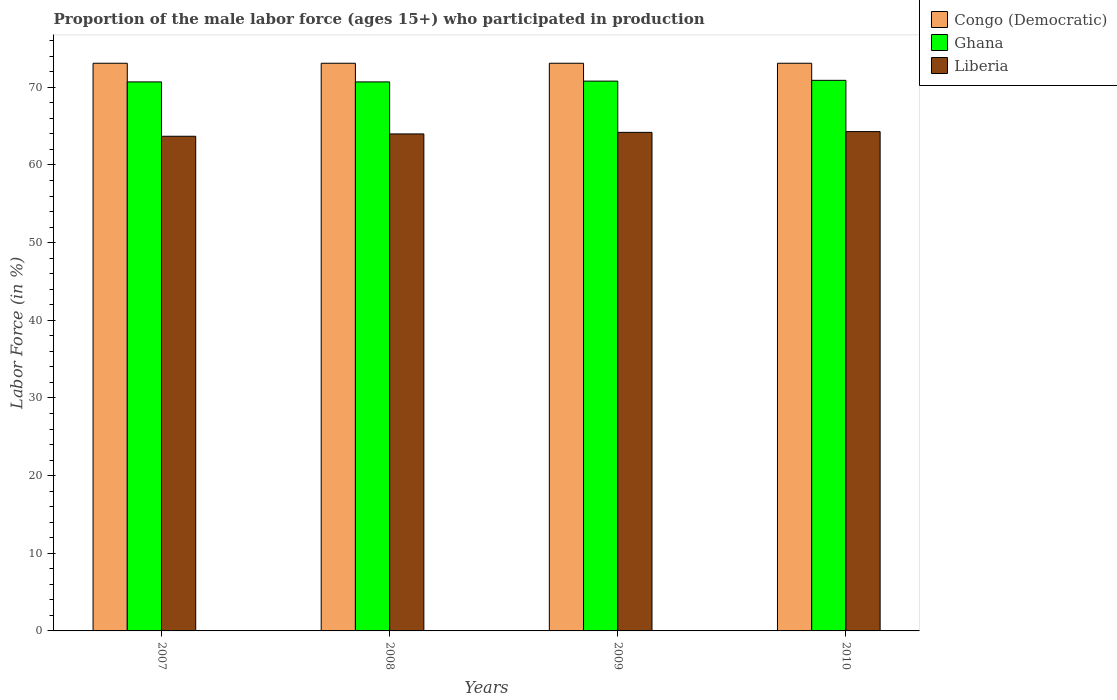How many different coloured bars are there?
Give a very brief answer. 3. Are the number of bars per tick equal to the number of legend labels?
Give a very brief answer. Yes. How many bars are there on the 3rd tick from the left?
Keep it short and to the point. 3. What is the label of the 4th group of bars from the left?
Make the answer very short. 2010. In how many cases, is the number of bars for a given year not equal to the number of legend labels?
Your answer should be very brief. 0. What is the proportion of the male labor force who participated in production in Ghana in 2007?
Provide a short and direct response. 70.7. Across all years, what is the maximum proportion of the male labor force who participated in production in Congo (Democratic)?
Offer a terse response. 73.1. Across all years, what is the minimum proportion of the male labor force who participated in production in Congo (Democratic)?
Make the answer very short. 73.1. What is the total proportion of the male labor force who participated in production in Congo (Democratic) in the graph?
Your response must be concise. 292.4. What is the difference between the proportion of the male labor force who participated in production in Congo (Democratic) in 2007 and that in 2010?
Provide a succinct answer. 0. What is the difference between the proportion of the male labor force who participated in production in Liberia in 2007 and the proportion of the male labor force who participated in production in Ghana in 2009?
Offer a terse response. -7.1. What is the average proportion of the male labor force who participated in production in Liberia per year?
Offer a very short reply. 64.05. In the year 2008, what is the difference between the proportion of the male labor force who participated in production in Congo (Democratic) and proportion of the male labor force who participated in production in Liberia?
Make the answer very short. 9.1. What is the ratio of the proportion of the male labor force who participated in production in Liberia in 2007 to that in 2009?
Ensure brevity in your answer.  0.99. Is the difference between the proportion of the male labor force who participated in production in Congo (Democratic) in 2007 and 2009 greater than the difference between the proportion of the male labor force who participated in production in Liberia in 2007 and 2009?
Your response must be concise. Yes. What is the difference between the highest and the second highest proportion of the male labor force who participated in production in Liberia?
Offer a terse response. 0.1. In how many years, is the proportion of the male labor force who participated in production in Ghana greater than the average proportion of the male labor force who participated in production in Ghana taken over all years?
Your answer should be compact. 2. What does the 1st bar from the left in 2009 represents?
Your answer should be very brief. Congo (Democratic). What does the 1st bar from the right in 2009 represents?
Keep it short and to the point. Liberia. How many bars are there?
Keep it short and to the point. 12. Are all the bars in the graph horizontal?
Your answer should be compact. No. What is the difference between two consecutive major ticks on the Y-axis?
Ensure brevity in your answer.  10. Where does the legend appear in the graph?
Provide a succinct answer. Top right. How are the legend labels stacked?
Make the answer very short. Vertical. What is the title of the graph?
Give a very brief answer. Proportion of the male labor force (ages 15+) who participated in production. Does "Curacao" appear as one of the legend labels in the graph?
Offer a terse response. No. What is the label or title of the Y-axis?
Offer a terse response. Labor Force (in %). What is the Labor Force (in %) of Congo (Democratic) in 2007?
Your answer should be compact. 73.1. What is the Labor Force (in %) of Ghana in 2007?
Make the answer very short. 70.7. What is the Labor Force (in %) in Liberia in 2007?
Give a very brief answer. 63.7. What is the Labor Force (in %) in Congo (Democratic) in 2008?
Ensure brevity in your answer.  73.1. What is the Labor Force (in %) in Ghana in 2008?
Keep it short and to the point. 70.7. What is the Labor Force (in %) in Congo (Democratic) in 2009?
Offer a very short reply. 73.1. What is the Labor Force (in %) of Ghana in 2009?
Offer a very short reply. 70.8. What is the Labor Force (in %) in Liberia in 2009?
Give a very brief answer. 64.2. What is the Labor Force (in %) in Congo (Democratic) in 2010?
Your answer should be compact. 73.1. What is the Labor Force (in %) of Ghana in 2010?
Provide a short and direct response. 70.9. What is the Labor Force (in %) in Liberia in 2010?
Your answer should be compact. 64.3. Across all years, what is the maximum Labor Force (in %) in Congo (Democratic)?
Provide a short and direct response. 73.1. Across all years, what is the maximum Labor Force (in %) of Ghana?
Your answer should be very brief. 70.9. Across all years, what is the maximum Labor Force (in %) in Liberia?
Give a very brief answer. 64.3. Across all years, what is the minimum Labor Force (in %) in Congo (Democratic)?
Your answer should be very brief. 73.1. Across all years, what is the minimum Labor Force (in %) in Ghana?
Provide a short and direct response. 70.7. Across all years, what is the minimum Labor Force (in %) of Liberia?
Your answer should be very brief. 63.7. What is the total Labor Force (in %) of Congo (Democratic) in the graph?
Your answer should be very brief. 292.4. What is the total Labor Force (in %) in Ghana in the graph?
Ensure brevity in your answer.  283.1. What is the total Labor Force (in %) of Liberia in the graph?
Your response must be concise. 256.2. What is the difference between the Labor Force (in %) of Liberia in 2007 and that in 2008?
Your response must be concise. -0.3. What is the difference between the Labor Force (in %) in Congo (Democratic) in 2007 and that in 2009?
Provide a succinct answer. 0. What is the difference between the Labor Force (in %) in Liberia in 2007 and that in 2009?
Your answer should be compact. -0.5. What is the difference between the Labor Force (in %) of Congo (Democratic) in 2007 and that in 2010?
Provide a short and direct response. 0. What is the difference between the Labor Force (in %) in Ghana in 2007 and that in 2010?
Make the answer very short. -0.2. What is the difference between the Labor Force (in %) in Congo (Democratic) in 2008 and that in 2009?
Keep it short and to the point. 0. What is the difference between the Labor Force (in %) of Ghana in 2008 and that in 2009?
Ensure brevity in your answer.  -0.1. What is the difference between the Labor Force (in %) of Liberia in 2008 and that in 2009?
Offer a very short reply. -0.2. What is the difference between the Labor Force (in %) of Liberia in 2008 and that in 2010?
Provide a succinct answer. -0.3. What is the difference between the Labor Force (in %) of Congo (Democratic) in 2009 and that in 2010?
Ensure brevity in your answer.  0. What is the difference between the Labor Force (in %) in Ghana in 2007 and the Labor Force (in %) in Liberia in 2009?
Make the answer very short. 6.5. What is the difference between the Labor Force (in %) of Congo (Democratic) in 2007 and the Labor Force (in %) of Liberia in 2010?
Give a very brief answer. 8.8. What is the difference between the Labor Force (in %) of Congo (Democratic) in 2008 and the Labor Force (in %) of Ghana in 2009?
Offer a terse response. 2.3. What is the difference between the Labor Force (in %) of Congo (Democratic) in 2008 and the Labor Force (in %) of Liberia in 2009?
Offer a terse response. 8.9. What is the difference between the Labor Force (in %) of Congo (Democratic) in 2008 and the Labor Force (in %) of Liberia in 2010?
Provide a succinct answer. 8.8. What is the difference between the Labor Force (in %) in Ghana in 2008 and the Labor Force (in %) in Liberia in 2010?
Your response must be concise. 6.4. What is the difference between the Labor Force (in %) of Congo (Democratic) in 2009 and the Labor Force (in %) of Ghana in 2010?
Your answer should be compact. 2.2. What is the difference between the Labor Force (in %) in Congo (Democratic) in 2009 and the Labor Force (in %) in Liberia in 2010?
Your response must be concise. 8.8. What is the difference between the Labor Force (in %) in Ghana in 2009 and the Labor Force (in %) in Liberia in 2010?
Provide a succinct answer. 6.5. What is the average Labor Force (in %) of Congo (Democratic) per year?
Keep it short and to the point. 73.1. What is the average Labor Force (in %) of Ghana per year?
Keep it short and to the point. 70.78. What is the average Labor Force (in %) in Liberia per year?
Ensure brevity in your answer.  64.05. In the year 2007, what is the difference between the Labor Force (in %) in Congo (Democratic) and Labor Force (in %) in Ghana?
Keep it short and to the point. 2.4. In the year 2007, what is the difference between the Labor Force (in %) in Congo (Democratic) and Labor Force (in %) in Liberia?
Keep it short and to the point. 9.4. In the year 2007, what is the difference between the Labor Force (in %) of Ghana and Labor Force (in %) of Liberia?
Keep it short and to the point. 7. In the year 2008, what is the difference between the Labor Force (in %) of Congo (Democratic) and Labor Force (in %) of Liberia?
Offer a terse response. 9.1. In the year 2008, what is the difference between the Labor Force (in %) of Ghana and Labor Force (in %) of Liberia?
Your answer should be very brief. 6.7. In the year 2009, what is the difference between the Labor Force (in %) in Congo (Democratic) and Labor Force (in %) in Liberia?
Offer a very short reply. 8.9. In the year 2010, what is the difference between the Labor Force (in %) in Congo (Democratic) and Labor Force (in %) in Liberia?
Ensure brevity in your answer.  8.8. What is the ratio of the Labor Force (in %) in Congo (Democratic) in 2007 to that in 2008?
Offer a terse response. 1. What is the ratio of the Labor Force (in %) of Ghana in 2007 to that in 2008?
Your answer should be compact. 1. What is the ratio of the Labor Force (in %) of Liberia in 2007 to that in 2008?
Offer a very short reply. 1. What is the ratio of the Labor Force (in %) in Congo (Democratic) in 2007 to that in 2009?
Keep it short and to the point. 1. What is the ratio of the Labor Force (in %) of Congo (Democratic) in 2007 to that in 2010?
Your response must be concise. 1. What is the ratio of the Labor Force (in %) of Ghana in 2007 to that in 2010?
Provide a short and direct response. 1. What is the ratio of the Labor Force (in %) of Congo (Democratic) in 2008 to that in 2009?
Offer a terse response. 1. 